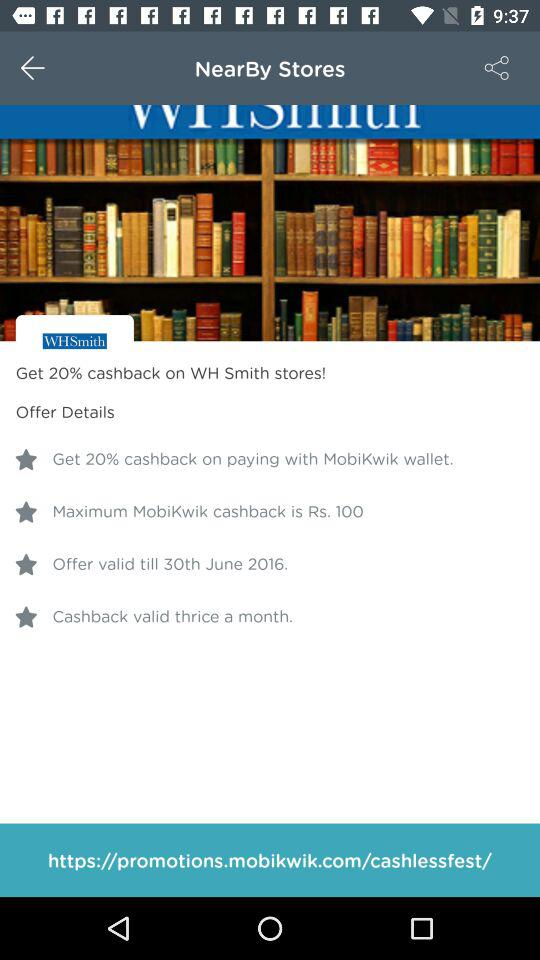What's the hyperlink address? The hyperlink address is "https://promotions.mobikwik.com/cashlessfest/". 